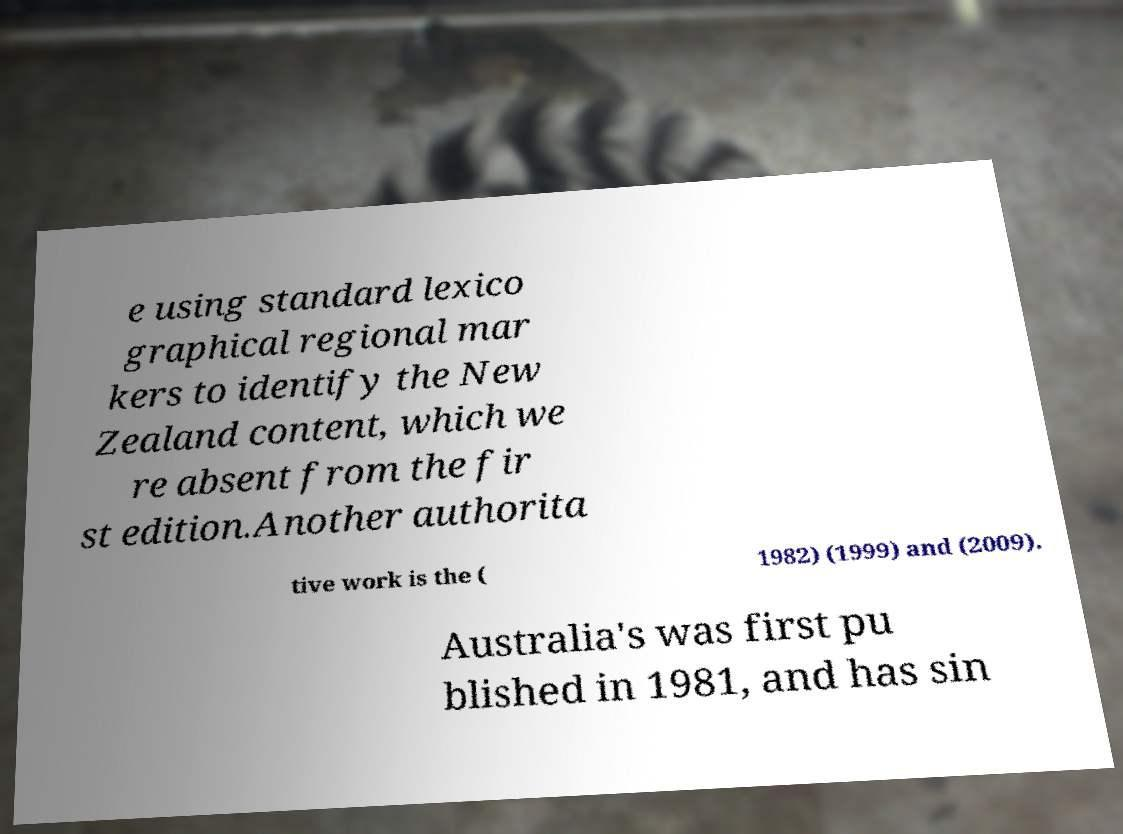Could you assist in decoding the text presented in this image and type it out clearly? e using standard lexico graphical regional mar kers to identify the New Zealand content, which we re absent from the fir st edition.Another authorita tive work is the ( 1982) (1999) and (2009). Australia's was first pu blished in 1981, and has sin 